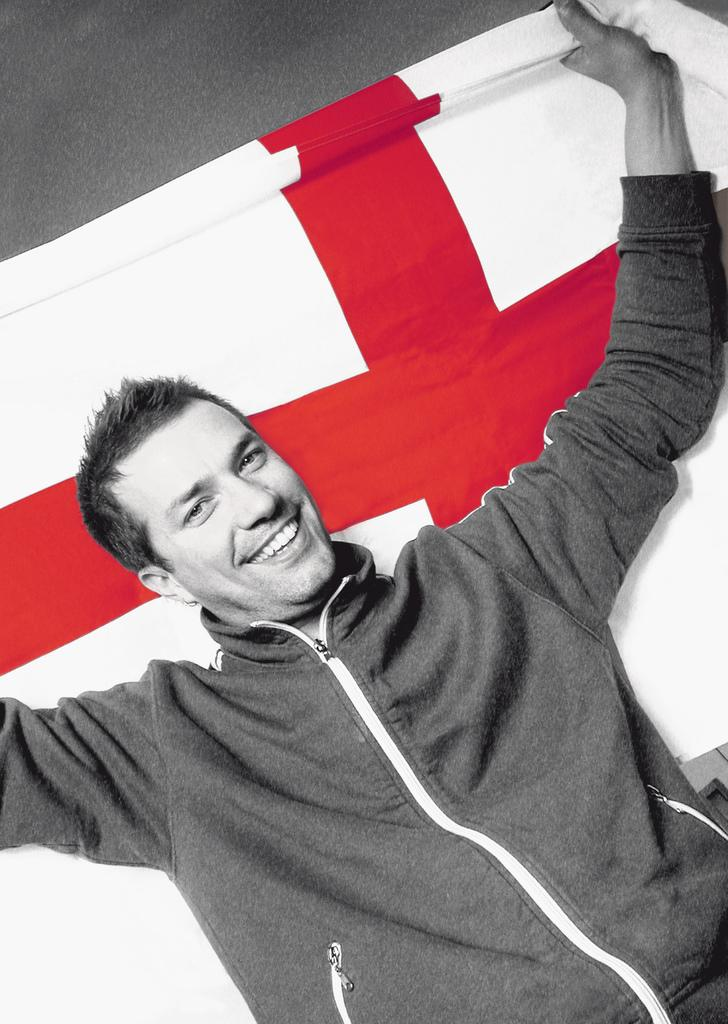Where was the image taken? The image was taken indoors. What can be seen in the background of the image? There is a wall in the background of the image. Who is the main subject in the image? A man is standing in the middle of the image. What is the man holding in his hands? The man is holding a flag in his hands. What is the man's facial expression? The man has a smiling face. What type of cough medicine is the man taking in the image? There is no indication in the image that the man is taking any cough medicine, as the focus is on him holding a flag and his smiling face. 